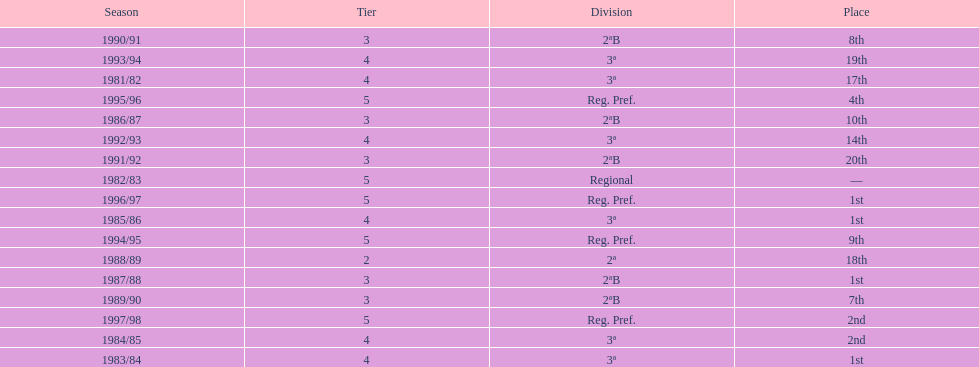When is the last year that the team has been division 2? 1991/92. 